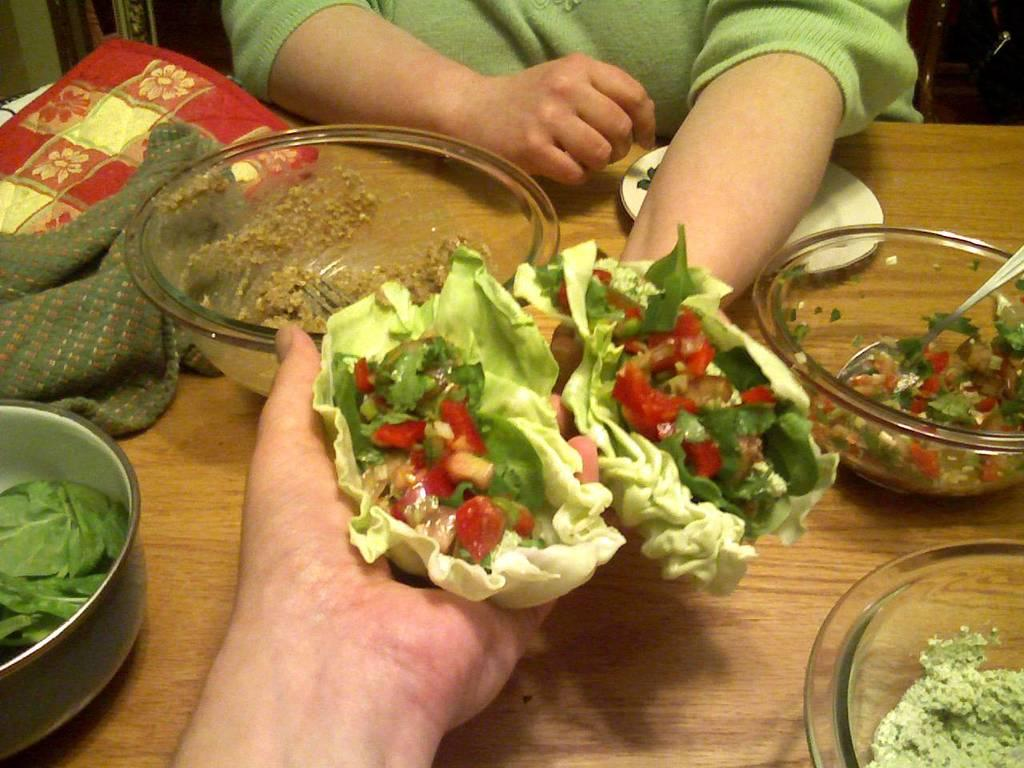What type of furniture is visible in the image? There is a table present in the image. What objects are on the table? There are bowls, a plate, and food items on the table. Is there any covering on the table? Yes, a cloth is on the table. What are the two persons in the image doing? Two persons' hands are holding food items in the center of the image. How much does the dime cost on the table in the image? There is no dime present in the image. What level of experience does the beginner have in the image? There is no indication of anyone's experience level in the image. 